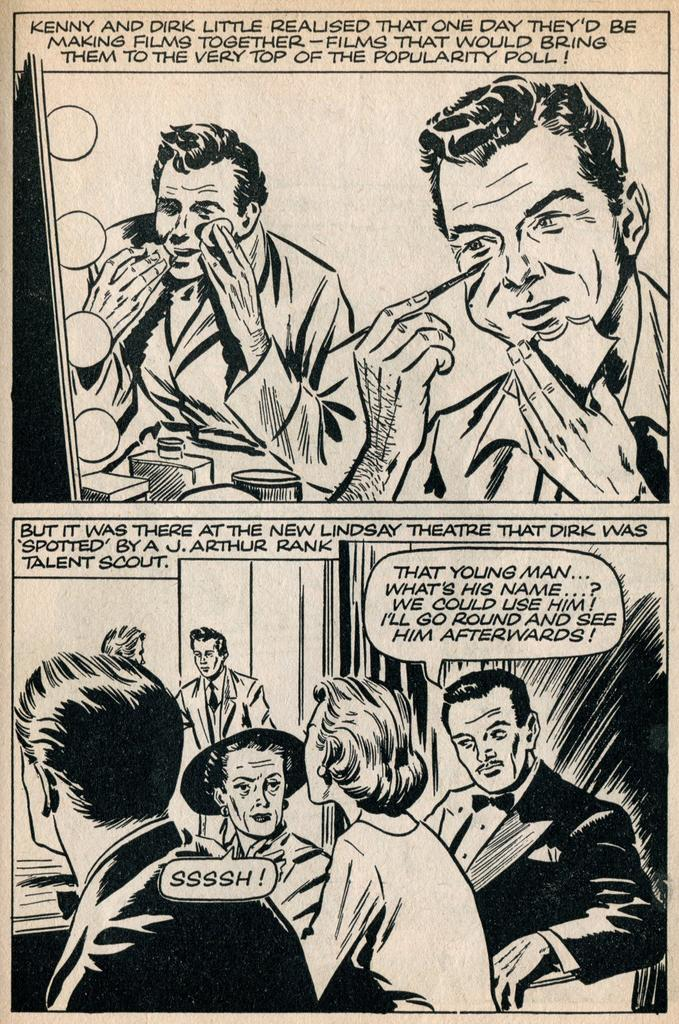What can be seen in the image besides text? There are pictures of persons in the image. What is written on the image? The text written on the image is not specified in the provided facts. Where is the camp located in the image? There is no camp present in the image. What type of cub is depicted in the image? There is no cub present in the image. 